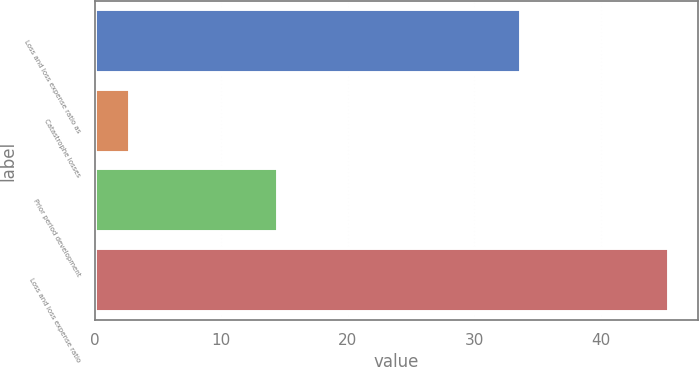Convert chart to OTSL. <chart><loc_0><loc_0><loc_500><loc_500><bar_chart><fcel>Loss and loss expense ratio as<fcel>Catastrophe losses<fcel>Prior period development<fcel>Loss and loss expense ratio<nl><fcel>33.7<fcel>2.8<fcel>14.5<fcel>45.4<nl></chart> 